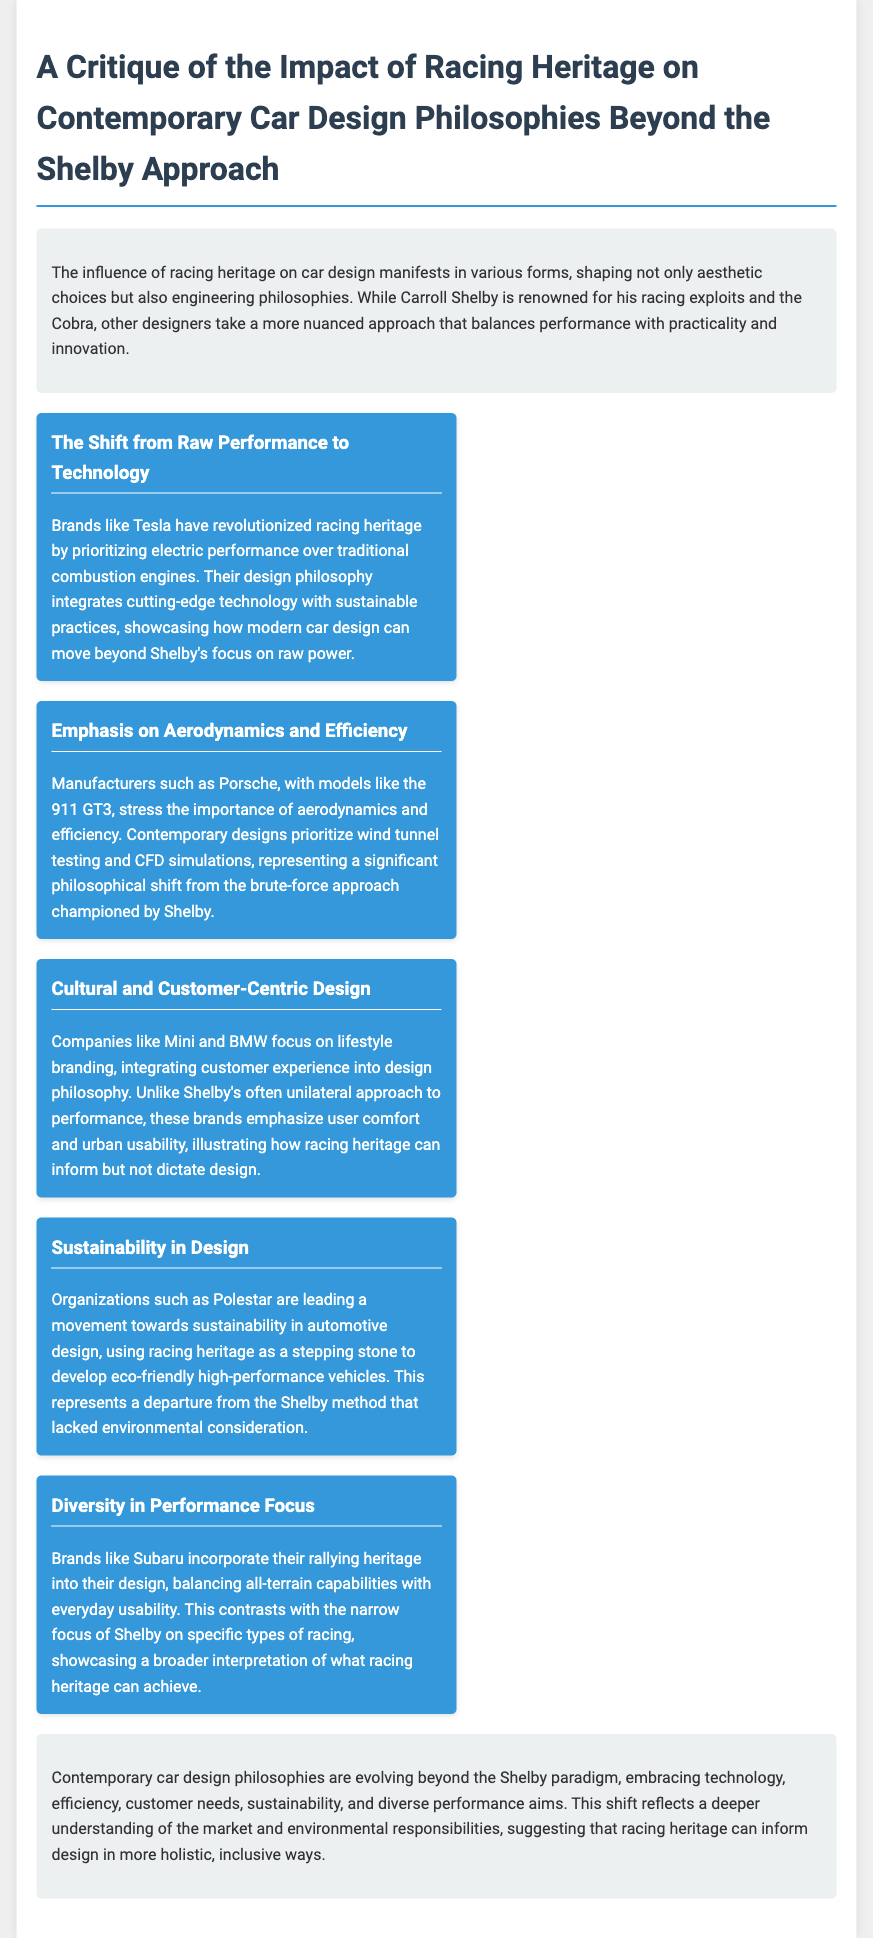What is the title of the document? The title of the document is specified in the header section, summarizing the main focus of the critique.
Answer: A Critique of the Impact of Racing Heritage on Contemporary Car Design Philosophies Beyond the Shelby Approach Which company is mentioned as revolutionizing racing heritage? The document highlights Tesla as a brand that has taken a different approach regarding racing heritage.
Answer: Tesla What key aspect does Porsche prioritize in its designs? The document outlines Porsche's emphasis on aerodynamics and efficiency in its car designs.
Answer: Aerodynamics and efficiency Which brand is noted for focusing on customer-centric design? Mini and BMW are mentioned as examples of companies with a lifestyle branding approach, integrating customer experience.
Answer: Mini and BMW What is a significant criticism of the Shelby design philosophy? The document implies that the Shelby approach lacked consideration for sustainability in car design.
Answer: Sustainability 